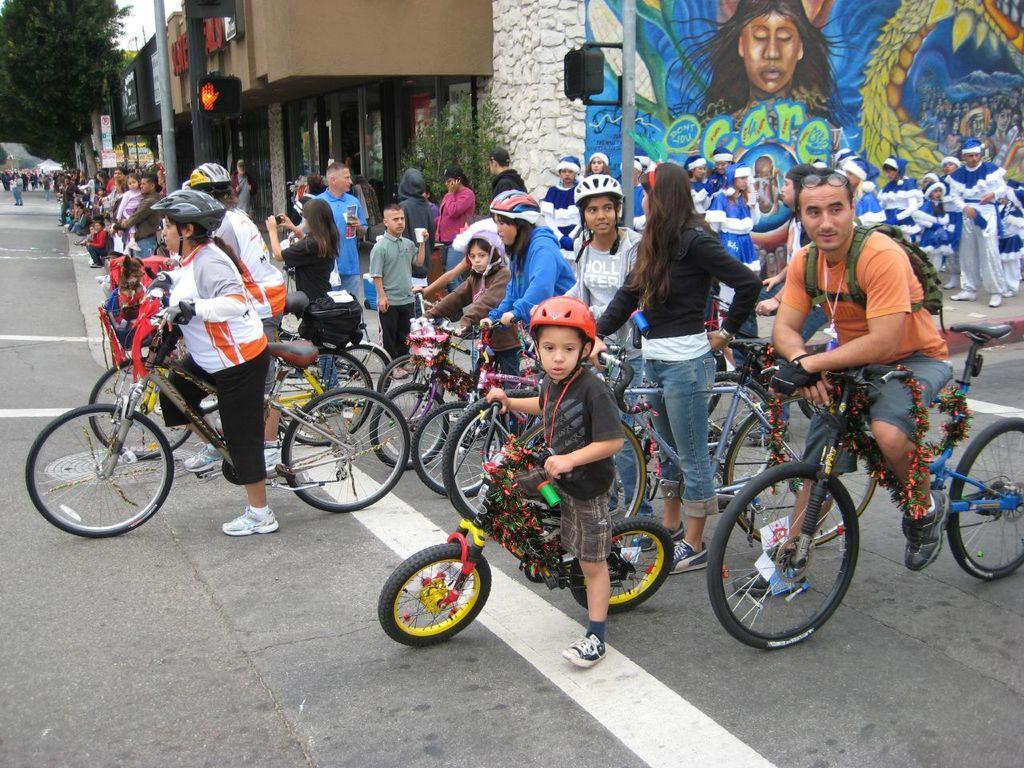What is the person in the image doing? The person is sitting on a bicycle. What safety precaution is the person taking? The person is wearing a helmet. Are there any other people in the image? Yes, there are people standing nearby. What can be seen in the background of the image? There is a building with a painting on the wall and trees visible in the distance. Can you tell me how many trucks are parked near the river in the image? There is no river or trucks present in the image. What type of skirt is the person wearing while sitting on the bicycle? The person is not wearing a skirt; they are wearing a helmet and sitting on a bicycle. 